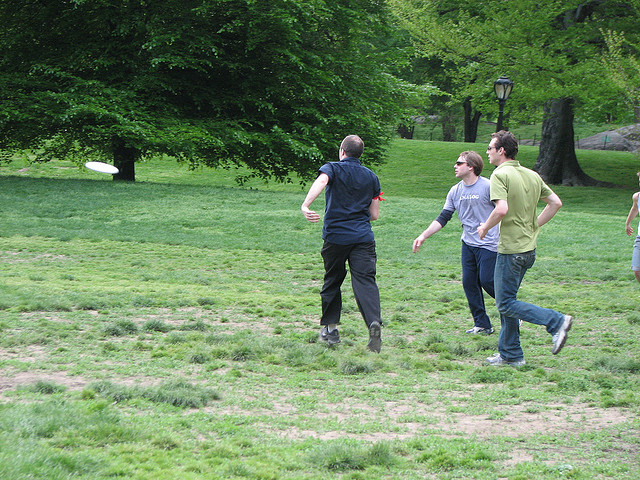<image>What animal is in the air? There is no animal in the air in the image. It could be a bird or a frisbee. What animal is in the air? I don't know what animal is in the air. There are no animals visible in the image. 